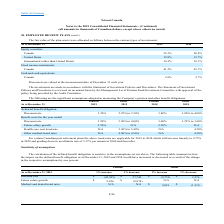From Loral Space Communications's financial document, How will the trend rates for Canadian post-retirement plans change between the current period to 2029 and in 2040 and after respectively? The document shows two values: Increase linearly to 4.75% and grading down to an ultimate rate of 3.57% per annum in 2040 and thereafter.. From the document: "in 2029 and grading down to an ultimate rate of 3.57% per annum in 2040 and thereafter. d rates are applicable for 2019 to 2024 which will increase li..." Also, What are the respective pension discount rates for actuarial benefit obligation in 2019 and 2018 respectively? The document shows two values: 3.20% and 3.80%. From the document: "Discount rate 3.20 % 2.95% to 3.20% 3.80 % 3.80% to 4.00% Discount rate 3.20 % 2.95% to 3.20% 3.80 % 3.80% to 4.00%..." Also, What are the respective pension discount rates for benefit costs in 2019 and 2018 respectively? The document shows two values: 3.90% and 3.60%. From the document: "Discount rate 3.90 % 3.90% to 4.00% 3.60 % 3.25% to 3.60% iscount rate 3.90 % 3.90% to 4.00% 3.60 % 3.25% to 3.60%..." Also, can you calculate: What is the total pension discount rate for actuarial benefit obligation for 2018 and 2019? Based on the calculation: 3.20 + 3.80 , the result is 7 (percentage). This is based on the information: "Discount rate 3.20 % 2.95% to 3.20% 3.80 % 3.80% to 4.00% Discount rate 3.20 % 2.95% to 3.20% 3.80 % 3.80% to 4.00%..." The key data points involved are: 3.20, 3.80. Also, can you calculate: What is the percentage change in the pension discount rate for actuarial benefit obligations between 2018 and 2019? Based on the calculation: 3.20 - 3.80 , the result is -0.6 (percentage). This is based on the information: "Discount rate 3.20 % 2.95% to 3.20% 3.80 % 3.80% to 4.00% Discount rate 3.20 % 2.95% to 3.20% 3.80 % 3.80% to 4.00%..." The key data points involved are: 3.20, 3.80. Also, can you calculate: What is the difference in future salary growth assumed under pension 2018 and 2019? I cannot find a specific answer to this question in the financial document. 